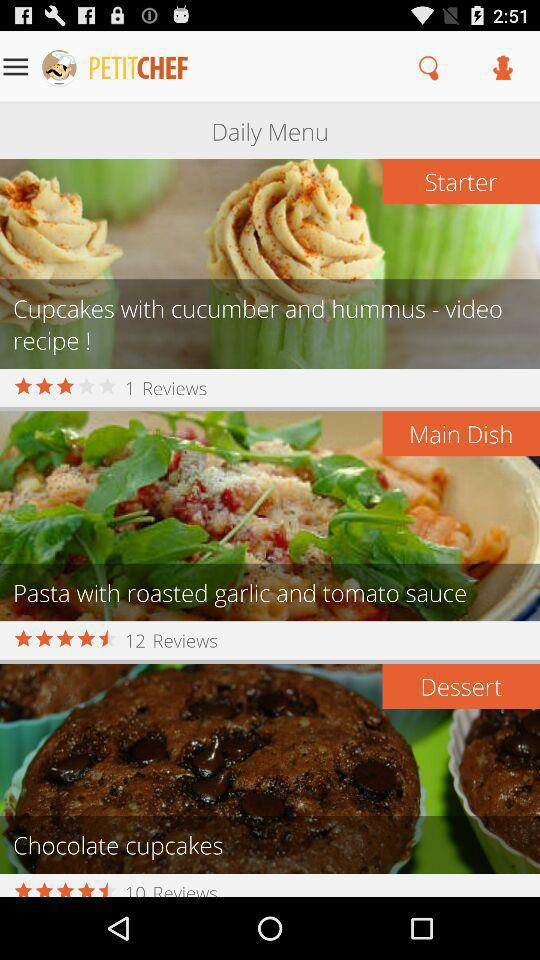What is the rating for the starter? The rating is 3 stars. 